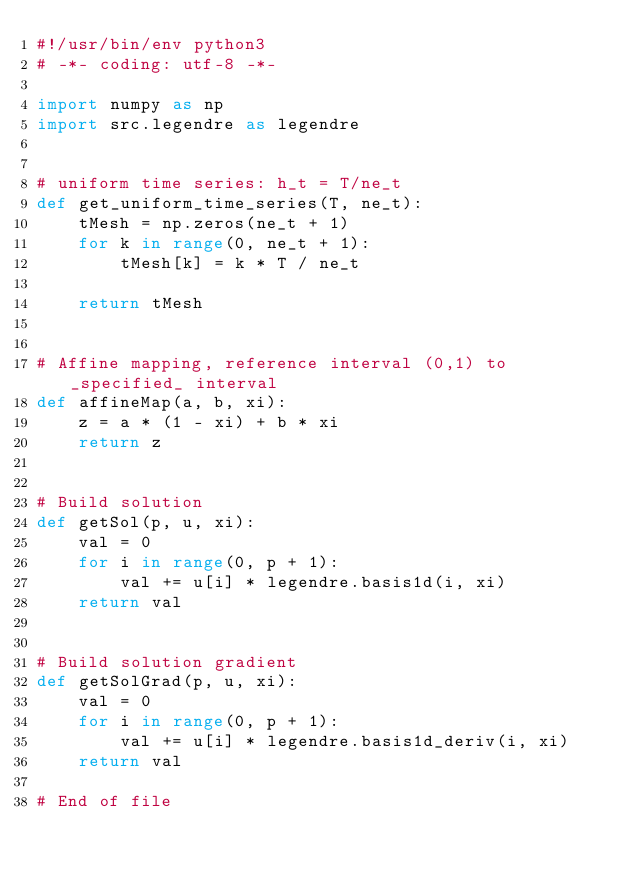<code> <loc_0><loc_0><loc_500><loc_500><_Python_>#!/usr/bin/env python3
# -*- coding: utf-8 -*-

import numpy as np
import src.legendre as legendre


# uniform time series: h_t = T/ne_t
def get_uniform_time_series(T, ne_t):
    tMesh = np.zeros(ne_t + 1)
    for k in range(0, ne_t + 1):
        tMesh[k] = k * T / ne_t

    return tMesh


# Affine mapping, reference interval (0,1) to _specified_ interval
def affineMap(a, b, xi):
    z = a * (1 - xi) + b * xi
    return z


# Build solution
def getSol(p, u, xi):
    val = 0
    for i in range(0, p + 1):
        val += u[i] * legendre.basis1d(i, xi)
    return val


# Build solution gradient
def getSolGrad(p, u, xi):
    val = 0
    for i in range(0, p + 1):
        val += u[i] * legendre.basis1d_deriv(i, xi)
    return val

# End of file
</code> 